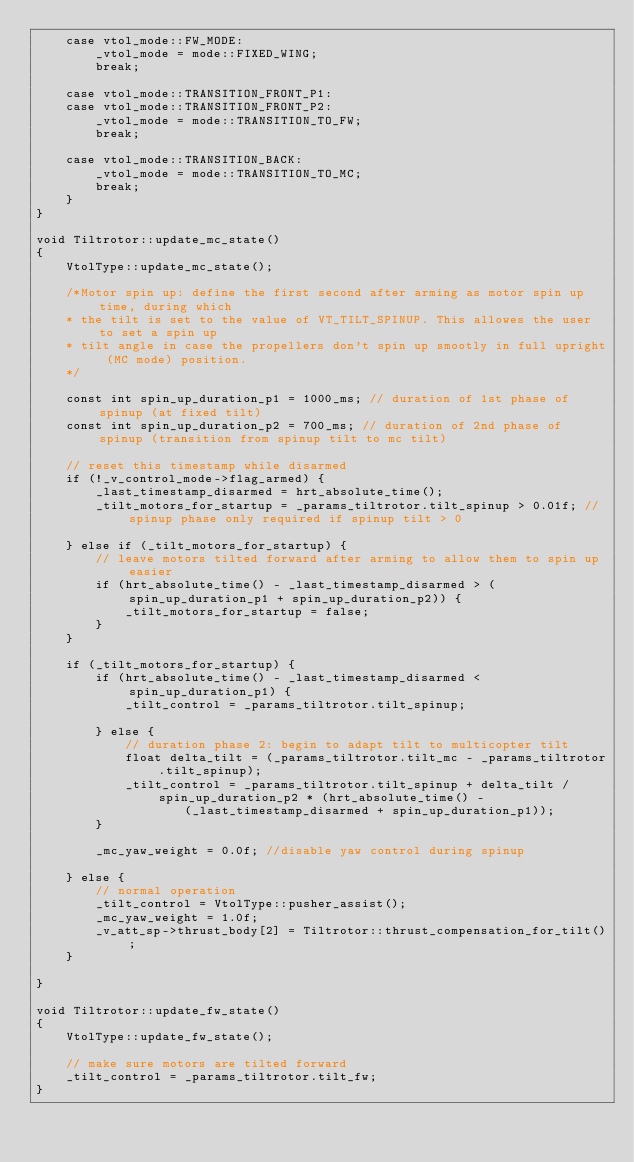Convert code to text. <code><loc_0><loc_0><loc_500><loc_500><_C++_>	case vtol_mode::FW_MODE:
		_vtol_mode = mode::FIXED_WING;
		break;

	case vtol_mode::TRANSITION_FRONT_P1:
	case vtol_mode::TRANSITION_FRONT_P2:
		_vtol_mode = mode::TRANSITION_TO_FW;
		break;

	case vtol_mode::TRANSITION_BACK:
		_vtol_mode = mode::TRANSITION_TO_MC;
		break;
	}
}

void Tiltrotor::update_mc_state()
{
	VtolType::update_mc_state();

	/*Motor spin up: define the first second after arming as motor spin up time, during which
	* the tilt is set to the value of VT_TILT_SPINUP. This allowes the user to set a spin up
	* tilt angle in case the propellers don't spin up smootly in full upright (MC mode) position.
	*/

	const int spin_up_duration_p1 = 1000_ms; // duration of 1st phase of spinup (at fixed tilt)
	const int spin_up_duration_p2 = 700_ms; // duration of 2nd phase of spinup (transition from spinup tilt to mc tilt)

	// reset this timestamp while disarmed
	if (!_v_control_mode->flag_armed) {
		_last_timestamp_disarmed = hrt_absolute_time();
		_tilt_motors_for_startup = _params_tiltrotor.tilt_spinup > 0.01f; // spinup phase only required if spinup tilt > 0

	} else if (_tilt_motors_for_startup) {
		// leave motors tilted forward after arming to allow them to spin up easier
		if (hrt_absolute_time() - _last_timestamp_disarmed > (spin_up_duration_p1 + spin_up_duration_p2)) {
			_tilt_motors_for_startup = false;
		}
	}

	if (_tilt_motors_for_startup) {
		if (hrt_absolute_time() - _last_timestamp_disarmed < spin_up_duration_p1) {
			_tilt_control = _params_tiltrotor.tilt_spinup;

		} else {
			// duration phase 2: begin to adapt tilt to multicopter tilt
			float delta_tilt = (_params_tiltrotor.tilt_mc - _params_tiltrotor.tilt_spinup);
			_tilt_control = _params_tiltrotor.tilt_spinup + delta_tilt / spin_up_duration_p2 * (hrt_absolute_time() -
					(_last_timestamp_disarmed + spin_up_duration_p1));
		}

		_mc_yaw_weight = 0.0f; //disable yaw control during spinup

	} else {
		// normal operation
		_tilt_control = VtolType::pusher_assist();
		_mc_yaw_weight = 1.0f;
		_v_att_sp->thrust_body[2] = Tiltrotor::thrust_compensation_for_tilt();
	}

}

void Tiltrotor::update_fw_state()
{
	VtolType::update_fw_state();

	// make sure motors are tilted forward
	_tilt_control = _params_tiltrotor.tilt_fw;
}
</code> 